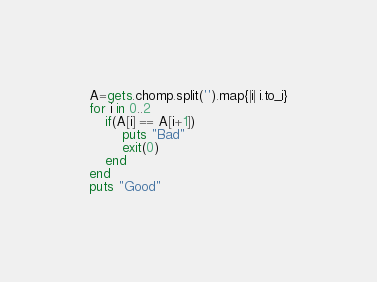<code> <loc_0><loc_0><loc_500><loc_500><_Ruby_>A=gets.chomp.split('').map{|i| i.to_i}
for i in 0..2
	if(A[i] == A[i+1])
		puts "Bad"
		exit(0)
	end
end
puts "Good"
</code> 